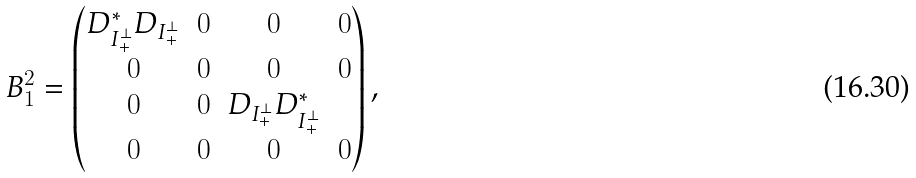<formula> <loc_0><loc_0><loc_500><loc_500>B _ { 1 } ^ { 2 } = \begin{pmatrix} D _ { I _ { + } ^ { \perp } } ^ { * } D _ { I _ { + } ^ { \perp } } & 0 & 0 & 0 \\ 0 & 0 & 0 & 0 \\ 0 & 0 & D _ { I _ { + } ^ { \perp } } D _ { I _ { + } ^ { \perp } } ^ { * } \\ 0 & 0 & 0 & 0 \end{pmatrix} ,</formula> 